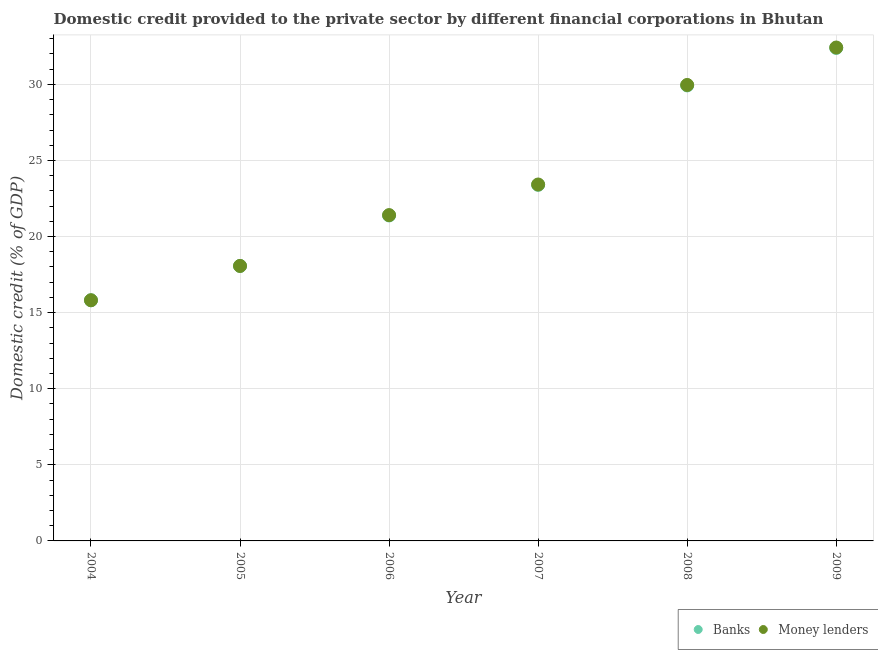Is the number of dotlines equal to the number of legend labels?
Ensure brevity in your answer.  Yes. What is the domestic credit provided by money lenders in 2006?
Provide a short and direct response. 21.41. Across all years, what is the maximum domestic credit provided by banks?
Offer a terse response. 32.39. Across all years, what is the minimum domestic credit provided by money lenders?
Your answer should be compact. 15.82. What is the total domestic credit provided by money lenders in the graph?
Make the answer very short. 141.1. What is the difference between the domestic credit provided by banks in 2005 and that in 2006?
Offer a very short reply. -3.32. What is the difference between the domestic credit provided by banks in 2008 and the domestic credit provided by money lenders in 2004?
Your answer should be very brief. 14.12. What is the average domestic credit provided by money lenders per year?
Your answer should be compact. 23.52. In the year 2007, what is the difference between the domestic credit provided by banks and domestic credit provided by money lenders?
Give a very brief answer. -0.02. What is the ratio of the domestic credit provided by money lenders in 2005 to that in 2009?
Make the answer very short. 0.56. Is the domestic credit provided by money lenders in 2008 less than that in 2009?
Provide a succinct answer. Yes. What is the difference between the highest and the second highest domestic credit provided by banks?
Your answer should be compact. 2.46. What is the difference between the highest and the lowest domestic credit provided by money lenders?
Your answer should be very brief. 16.61. Is the domestic credit provided by banks strictly greater than the domestic credit provided by money lenders over the years?
Ensure brevity in your answer.  No. How many dotlines are there?
Your answer should be compact. 2. What is the difference between two consecutive major ticks on the Y-axis?
Ensure brevity in your answer.  5. How many legend labels are there?
Your answer should be compact. 2. How are the legend labels stacked?
Your answer should be very brief. Horizontal. What is the title of the graph?
Provide a short and direct response. Domestic credit provided to the private sector by different financial corporations in Bhutan. Does "Exports of goods" appear as one of the legend labels in the graph?
Offer a very short reply. No. What is the label or title of the Y-axis?
Ensure brevity in your answer.  Domestic credit (% of GDP). What is the Domestic credit (% of GDP) of Banks in 2004?
Ensure brevity in your answer.  15.81. What is the Domestic credit (% of GDP) in Money lenders in 2004?
Ensure brevity in your answer.  15.82. What is the Domestic credit (% of GDP) in Banks in 2005?
Provide a short and direct response. 18.07. What is the Domestic credit (% of GDP) in Money lenders in 2005?
Offer a very short reply. 18.07. What is the Domestic credit (% of GDP) in Banks in 2006?
Provide a succinct answer. 21.39. What is the Domestic credit (% of GDP) in Money lenders in 2006?
Your answer should be compact. 21.41. What is the Domestic credit (% of GDP) of Banks in 2007?
Make the answer very short. 23.4. What is the Domestic credit (% of GDP) in Money lenders in 2007?
Offer a very short reply. 23.42. What is the Domestic credit (% of GDP) of Banks in 2008?
Provide a succinct answer. 29.93. What is the Domestic credit (% of GDP) in Money lenders in 2008?
Keep it short and to the point. 29.96. What is the Domestic credit (% of GDP) in Banks in 2009?
Your answer should be very brief. 32.39. What is the Domestic credit (% of GDP) in Money lenders in 2009?
Give a very brief answer. 32.42. Across all years, what is the maximum Domestic credit (% of GDP) in Banks?
Offer a very short reply. 32.39. Across all years, what is the maximum Domestic credit (% of GDP) of Money lenders?
Offer a very short reply. 32.42. Across all years, what is the minimum Domestic credit (% of GDP) in Banks?
Offer a very short reply. 15.81. Across all years, what is the minimum Domestic credit (% of GDP) of Money lenders?
Offer a very short reply. 15.82. What is the total Domestic credit (% of GDP) of Banks in the graph?
Your answer should be compact. 140.99. What is the total Domestic credit (% of GDP) of Money lenders in the graph?
Offer a terse response. 141.1. What is the difference between the Domestic credit (% of GDP) of Banks in 2004 and that in 2005?
Your answer should be compact. -2.26. What is the difference between the Domestic credit (% of GDP) of Money lenders in 2004 and that in 2005?
Offer a very short reply. -2.25. What is the difference between the Domestic credit (% of GDP) in Banks in 2004 and that in 2006?
Your response must be concise. -5.57. What is the difference between the Domestic credit (% of GDP) of Money lenders in 2004 and that in 2006?
Your answer should be compact. -5.59. What is the difference between the Domestic credit (% of GDP) in Banks in 2004 and that in 2007?
Your answer should be compact. -7.58. What is the difference between the Domestic credit (% of GDP) of Money lenders in 2004 and that in 2007?
Your answer should be compact. -7.61. What is the difference between the Domestic credit (% of GDP) in Banks in 2004 and that in 2008?
Give a very brief answer. -14.12. What is the difference between the Domestic credit (% of GDP) of Money lenders in 2004 and that in 2008?
Your response must be concise. -14.15. What is the difference between the Domestic credit (% of GDP) of Banks in 2004 and that in 2009?
Offer a very short reply. -16.58. What is the difference between the Domestic credit (% of GDP) of Money lenders in 2004 and that in 2009?
Your answer should be very brief. -16.61. What is the difference between the Domestic credit (% of GDP) in Banks in 2005 and that in 2006?
Your response must be concise. -3.32. What is the difference between the Domestic credit (% of GDP) of Money lenders in 2005 and that in 2006?
Your answer should be compact. -3.34. What is the difference between the Domestic credit (% of GDP) in Banks in 2005 and that in 2007?
Offer a terse response. -5.33. What is the difference between the Domestic credit (% of GDP) in Money lenders in 2005 and that in 2007?
Make the answer very short. -5.35. What is the difference between the Domestic credit (% of GDP) of Banks in 2005 and that in 2008?
Your response must be concise. -11.86. What is the difference between the Domestic credit (% of GDP) in Money lenders in 2005 and that in 2008?
Your answer should be compact. -11.89. What is the difference between the Domestic credit (% of GDP) of Banks in 2005 and that in 2009?
Provide a short and direct response. -14.33. What is the difference between the Domestic credit (% of GDP) of Money lenders in 2005 and that in 2009?
Your answer should be very brief. -14.35. What is the difference between the Domestic credit (% of GDP) of Banks in 2006 and that in 2007?
Your answer should be compact. -2.01. What is the difference between the Domestic credit (% of GDP) of Money lenders in 2006 and that in 2007?
Offer a very short reply. -2.01. What is the difference between the Domestic credit (% of GDP) in Banks in 2006 and that in 2008?
Keep it short and to the point. -8.55. What is the difference between the Domestic credit (% of GDP) of Money lenders in 2006 and that in 2008?
Offer a terse response. -8.55. What is the difference between the Domestic credit (% of GDP) of Banks in 2006 and that in 2009?
Make the answer very short. -11.01. What is the difference between the Domestic credit (% of GDP) of Money lenders in 2006 and that in 2009?
Your response must be concise. -11.01. What is the difference between the Domestic credit (% of GDP) of Banks in 2007 and that in 2008?
Your answer should be very brief. -6.53. What is the difference between the Domestic credit (% of GDP) in Money lenders in 2007 and that in 2008?
Your answer should be very brief. -6.54. What is the difference between the Domestic credit (% of GDP) of Banks in 2007 and that in 2009?
Provide a short and direct response. -9. What is the difference between the Domestic credit (% of GDP) in Money lenders in 2007 and that in 2009?
Provide a short and direct response. -9. What is the difference between the Domestic credit (% of GDP) of Banks in 2008 and that in 2009?
Provide a short and direct response. -2.46. What is the difference between the Domestic credit (% of GDP) of Money lenders in 2008 and that in 2009?
Your answer should be very brief. -2.46. What is the difference between the Domestic credit (% of GDP) in Banks in 2004 and the Domestic credit (% of GDP) in Money lenders in 2005?
Provide a short and direct response. -2.26. What is the difference between the Domestic credit (% of GDP) in Banks in 2004 and the Domestic credit (% of GDP) in Money lenders in 2006?
Make the answer very short. -5.6. What is the difference between the Domestic credit (% of GDP) of Banks in 2004 and the Domestic credit (% of GDP) of Money lenders in 2007?
Make the answer very short. -7.61. What is the difference between the Domestic credit (% of GDP) in Banks in 2004 and the Domestic credit (% of GDP) in Money lenders in 2008?
Your response must be concise. -14.15. What is the difference between the Domestic credit (% of GDP) of Banks in 2004 and the Domestic credit (% of GDP) of Money lenders in 2009?
Your response must be concise. -16.61. What is the difference between the Domestic credit (% of GDP) of Banks in 2005 and the Domestic credit (% of GDP) of Money lenders in 2006?
Your response must be concise. -3.34. What is the difference between the Domestic credit (% of GDP) in Banks in 2005 and the Domestic credit (% of GDP) in Money lenders in 2007?
Make the answer very short. -5.35. What is the difference between the Domestic credit (% of GDP) of Banks in 2005 and the Domestic credit (% of GDP) of Money lenders in 2008?
Give a very brief answer. -11.89. What is the difference between the Domestic credit (% of GDP) in Banks in 2005 and the Domestic credit (% of GDP) in Money lenders in 2009?
Give a very brief answer. -14.35. What is the difference between the Domestic credit (% of GDP) of Banks in 2006 and the Domestic credit (% of GDP) of Money lenders in 2007?
Offer a very short reply. -2.04. What is the difference between the Domestic credit (% of GDP) of Banks in 2006 and the Domestic credit (% of GDP) of Money lenders in 2008?
Keep it short and to the point. -8.58. What is the difference between the Domestic credit (% of GDP) of Banks in 2006 and the Domestic credit (% of GDP) of Money lenders in 2009?
Give a very brief answer. -11.04. What is the difference between the Domestic credit (% of GDP) in Banks in 2007 and the Domestic credit (% of GDP) in Money lenders in 2008?
Make the answer very short. -6.56. What is the difference between the Domestic credit (% of GDP) in Banks in 2007 and the Domestic credit (% of GDP) in Money lenders in 2009?
Provide a short and direct response. -9.02. What is the difference between the Domestic credit (% of GDP) in Banks in 2008 and the Domestic credit (% of GDP) in Money lenders in 2009?
Provide a succinct answer. -2.49. What is the average Domestic credit (% of GDP) of Banks per year?
Ensure brevity in your answer.  23.5. What is the average Domestic credit (% of GDP) in Money lenders per year?
Your response must be concise. 23.52. In the year 2004, what is the difference between the Domestic credit (% of GDP) in Banks and Domestic credit (% of GDP) in Money lenders?
Give a very brief answer. -0. In the year 2005, what is the difference between the Domestic credit (% of GDP) of Banks and Domestic credit (% of GDP) of Money lenders?
Your answer should be very brief. -0. In the year 2006, what is the difference between the Domestic credit (% of GDP) in Banks and Domestic credit (% of GDP) in Money lenders?
Offer a terse response. -0.02. In the year 2007, what is the difference between the Domestic credit (% of GDP) in Banks and Domestic credit (% of GDP) in Money lenders?
Make the answer very short. -0.02. In the year 2008, what is the difference between the Domestic credit (% of GDP) of Banks and Domestic credit (% of GDP) of Money lenders?
Offer a very short reply. -0.03. In the year 2009, what is the difference between the Domestic credit (% of GDP) in Banks and Domestic credit (% of GDP) in Money lenders?
Make the answer very short. -0.03. What is the ratio of the Domestic credit (% of GDP) in Banks in 2004 to that in 2005?
Your answer should be compact. 0.88. What is the ratio of the Domestic credit (% of GDP) of Money lenders in 2004 to that in 2005?
Offer a very short reply. 0.88. What is the ratio of the Domestic credit (% of GDP) of Banks in 2004 to that in 2006?
Your response must be concise. 0.74. What is the ratio of the Domestic credit (% of GDP) in Money lenders in 2004 to that in 2006?
Your answer should be compact. 0.74. What is the ratio of the Domestic credit (% of GDP) in Banks in 2004 to that in 2007?
Keep it short and to the point. 0.68. What is the ratio of the Domestic credit (% of GDP) of Money lenders in 2004 to that in 2007?
Give a very brief answer. 0.68. What is the ratio of the Domestic credit (% of GDP) in Banks in 2004 to that in 2008?
Your response must be concise. 0.53. What is the ratio of the Domestic credit (% of GDP) of Money lenders in 2004 to that in 2008?
Offer a terse response. 0.53. What is the ratio of the Domestic credit (% of GDP) in Banks in 2004 to that in 2009?
Provide a succinct answer. 0.49. What is the ratio of the Domestic credit (% of GDP) of Money lenders in 2004 to that in 2009?
Give a very brief answer. 0.49. What is the ratio of the Domestic credit (% of GDP) in Banks in 2005 to that in 2006?
Your answer should be compact. 0.84. What is the ratio of the Domestic credit (% of GDP) in Money lenders in 2005 to that in 2006?
Your answer should be compact. 0.84. What is the ratio of the Domestic credit (% of GDP) in Banks in 2005 to that in 2007?
Give a very brief answer. 0.77. What is the ratio of the Domestic credit (% of GDP) of Money lenders in 2005 to that in 2007?
Your response must be concise. 0.77. What is the ratio of the Domestic credit (% of GDP) in Banks in 2005 to that in 2008?
Your answer should be very brief. 0.6. What is the ratio of the Domestic credit (% of GDP) of Money lenders in 2005 to that in 2008?
Provide a succinct answer. 0.6. What is the ratio of the Domestic credit (% of GDP) in Banks in 2005 to that in 2009?
Offer a very short reply. 0.56. What is the ratio of the Domestic credit (% of GDP) of Money lenders in 2005 to that in 2009?
Your response must be concise. 0.56. What is the ratio of the Domestic credit (% of GDP) of Banks in 2006 to that in 2007?
Provide a short and direct response. 0.91. What is the ratio of the Domestic credit (% of GDP) of Money lenders in 2006 to that in 2007?
Your answer should be very brief. 0.91. What is the ratio of the Domestic credit (% of GDP) of Banks in 2006 to that in 2008?
Give a very brief answer. 0.71. What is the ratio of the Domestic credit (% of GDP) of Money lenders in 2006 to that in 2008?
Your answer should be very brief. 0.71. What is the ratio of the Domestic credit (% of GDP) of Banks in 2006 to that in 2009?
Your response must be concise. 0.66. What is the ratio of the Domestic credit (% of GDP) of Money lenders in 2006 to that in 2009?
Provide a short and direct response. 0.66. What is the ratio of the Domestic credit (% of GDP) in Banks in 2007 to that in 2008?
Make the answer very short. 0.78. What is the ratio of the Domestic credit (% of GDP) in Money lenders in 2007 to that in 2008?
Provide a short and direct response. 0.78. What is the ratio of the Domestic credit (% of GDP) of Banks in 2007 to that in 2009?
Offer a terse response. 0.72. What is the ratio of the Domestic credit (% of GDP) of Money lenders in 2007 to that in 2009?
Your response must be concise. 0.72. What is the ratio of the Domestic credit (% of GDP) of Banks in 2008 to that in 2009?
Ensure brevity in your answer.  0.92. What is the ratio of the Domestic credit (% of GDP) of Money lenders in 2008 to that in 2009?
Offer a very short reply. 0.92. What is the difference between the highest and the second highest Domestic credit (% of GDP) in Banks?
Your answer should be compact. 2.46. What is the difference between the highest and the second highest Domestic credit (% of GDP) of Money lenders?
Provide a short and direct response. 2.46. What is the difference between the highest and the lowest Domestic credit (% of GDP) of Banks?
Your answer should be compact. 16.58. What is the difference between the highest and the lowest Domestic credit (% of GDP) of Money lenders?
Offer a very short reply. 16.61. 